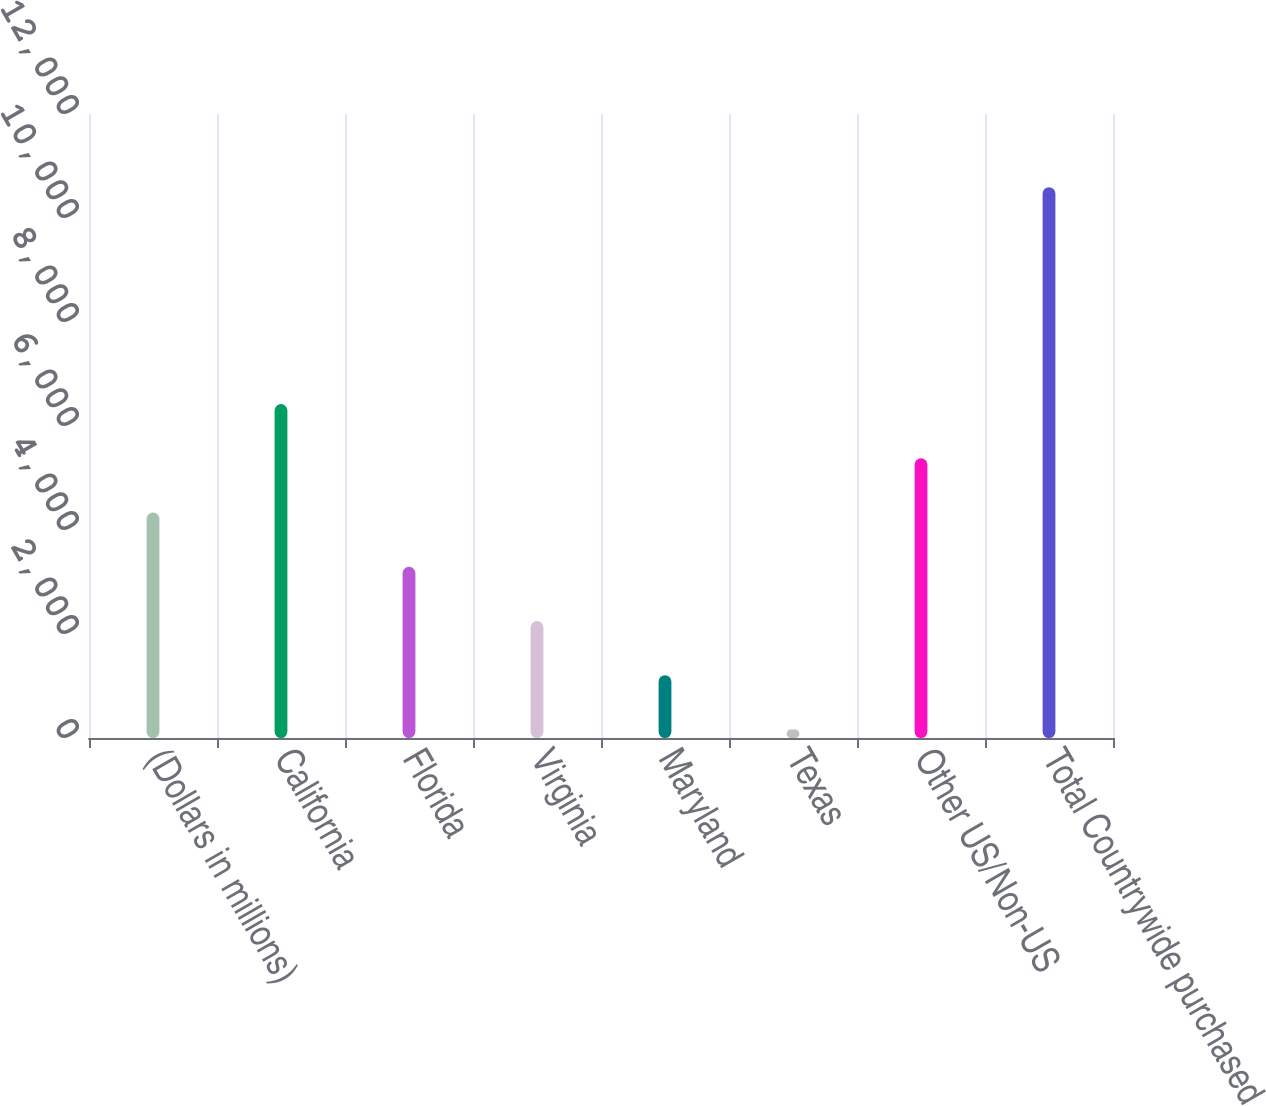<chart> <loc_0><loc_0><loc_500><loc_500><bar_chart><fcel>(Dollars in millions)<fcel>California<fcel>Florida<fcel>Virginia<fcel>Maryland<fcel>Texas<fcel>Other US/Non-US<fcel>Total Countrywide purchased<nl><fcel>4335.2<fcel>6420.8<fcel>3292.4<fcel>2249.6<fcel>1206.8<fcel>164<fcel>5378<fcel>10592<nl></chart> 